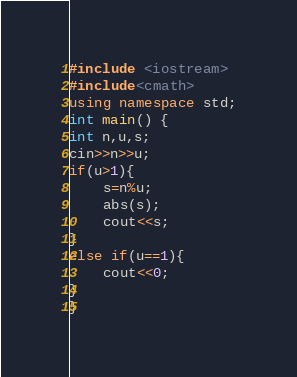Convert code to text. <code><loc_0><loc_0><loc_500><loc_500><_C++_>#include <iostream>
#include<cmath>
using namespace std;
int main() {
int n,u,s;
cin>>n>>u;
if(u>1){
    s=n%u;
    abs(s);
    cout<<s;
}
else if(u==1){
    cout<<0;
}
}
</code> 